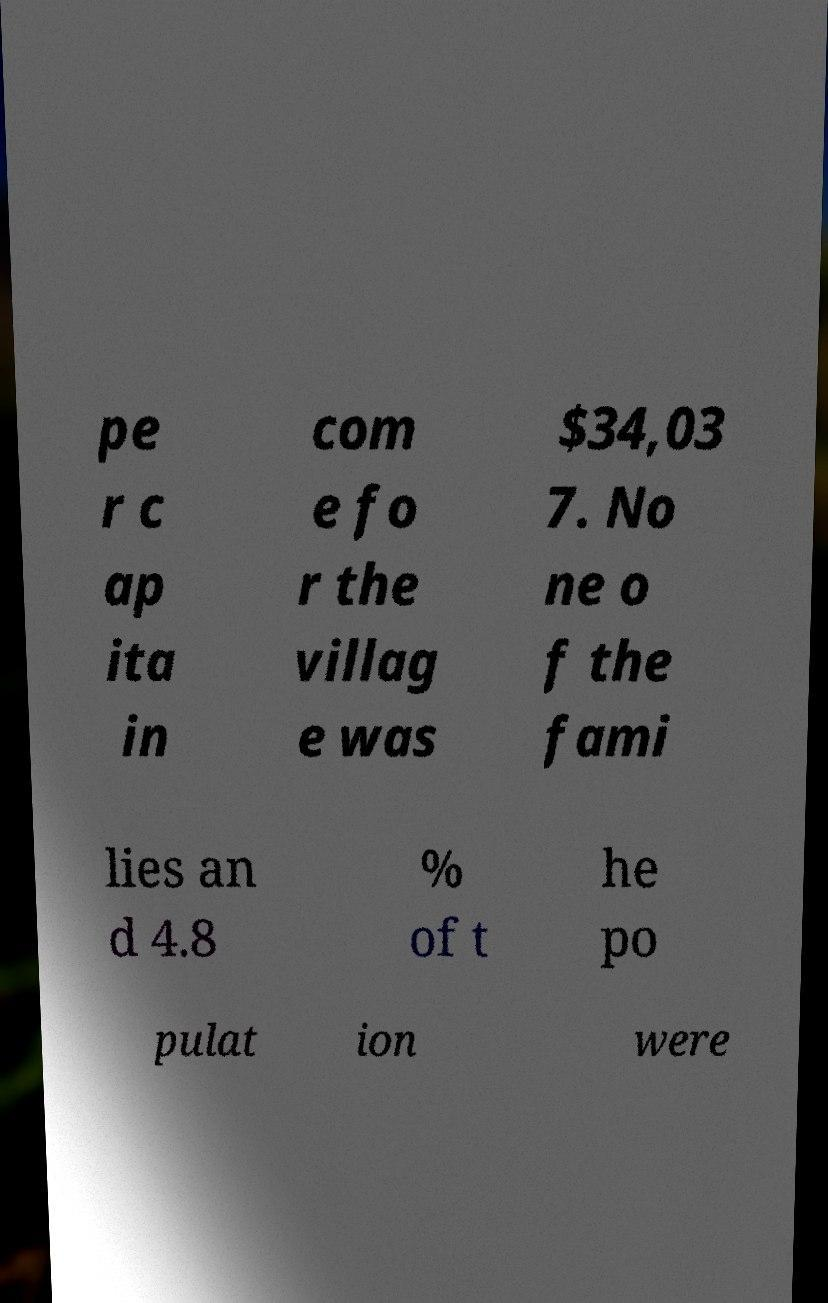Please identify and transcribe the text found in this image. pe r c ap ita in com e fo r the villag e was $34,03 7. No ne o f the fami lies an d 4.8 % of t he po pulat ion were 